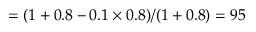<formula> <loc_0><loc_0><loc_500><loc_500>= ( 1 + 0 . 8 - 0 . 1 \times 0 . 8 ) / ( 1 + 0 . 8 ) = 9 5 \</formula> 